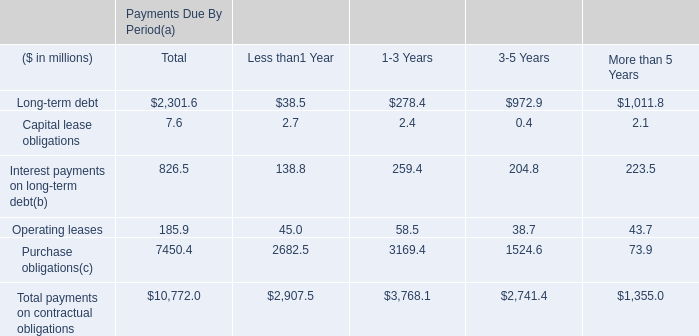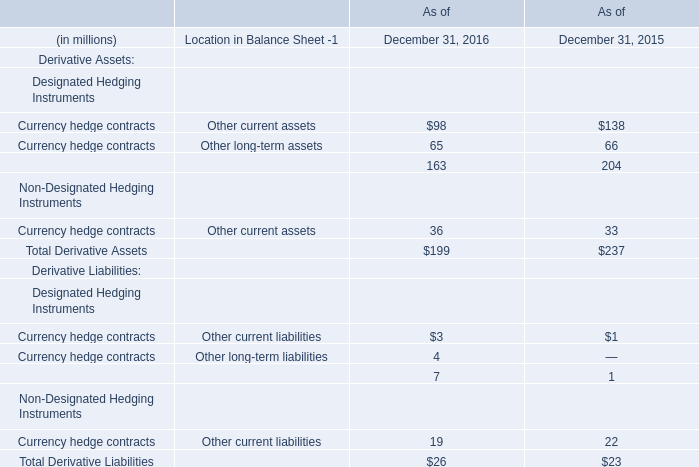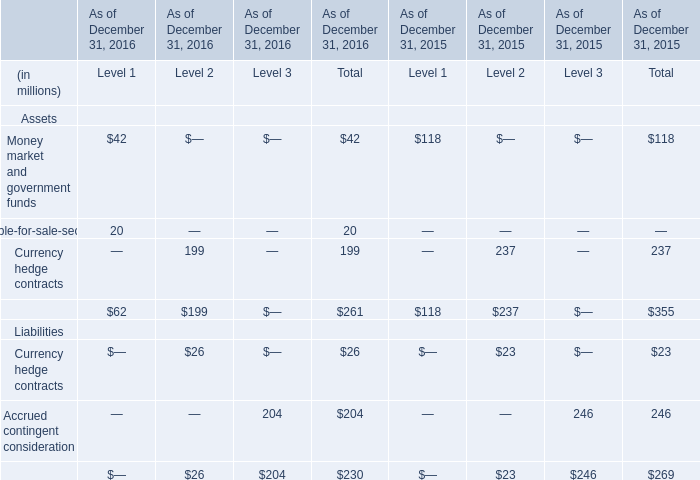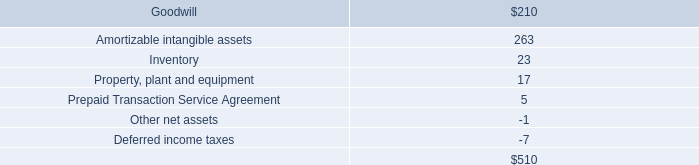how much cash would the company have retained had it not paid dividends in 2006 , 2005 , and 2004 ( in millions? ) 
Computations: ((41 + 42.5) + 38.9)
Answer: 122.4. 